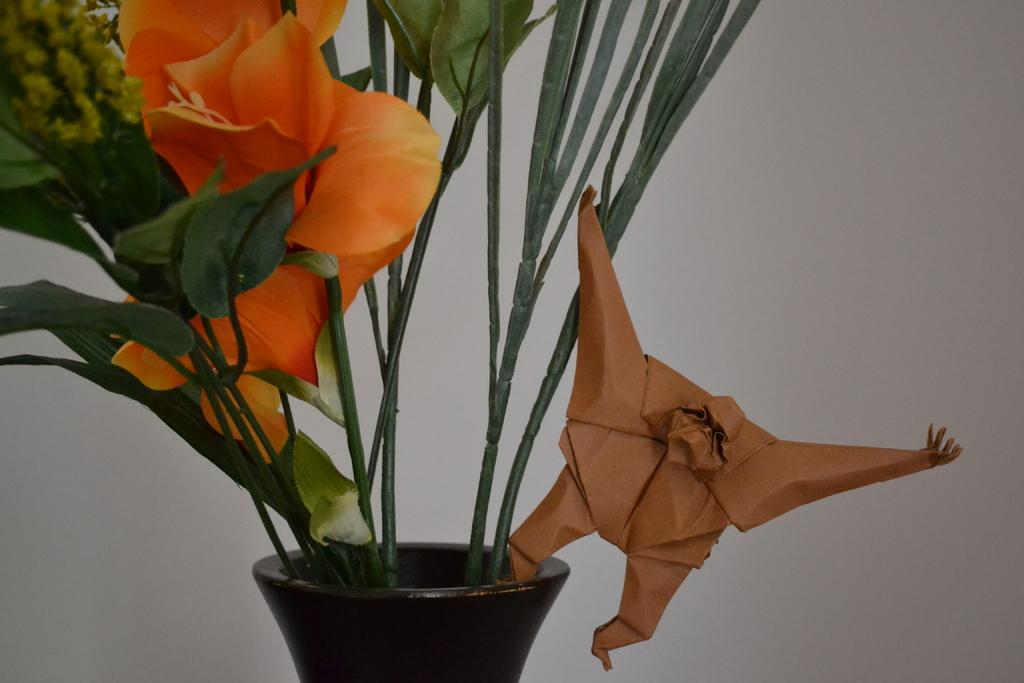What type of plant is in the image? There is a flower plant in the image. What parts of the flower plant can be seen? The flower plant has leaves and stems. What is the flower plant placed in? There is a pot in the image. What other object is present in the image? There is a paper craft in the image. What is the background of the image? The background of the image is a white wall. What type of veil is draped over the flower plant in the image? There is no veil present in the image; the flower plant is not covered or draped with any fabric. 